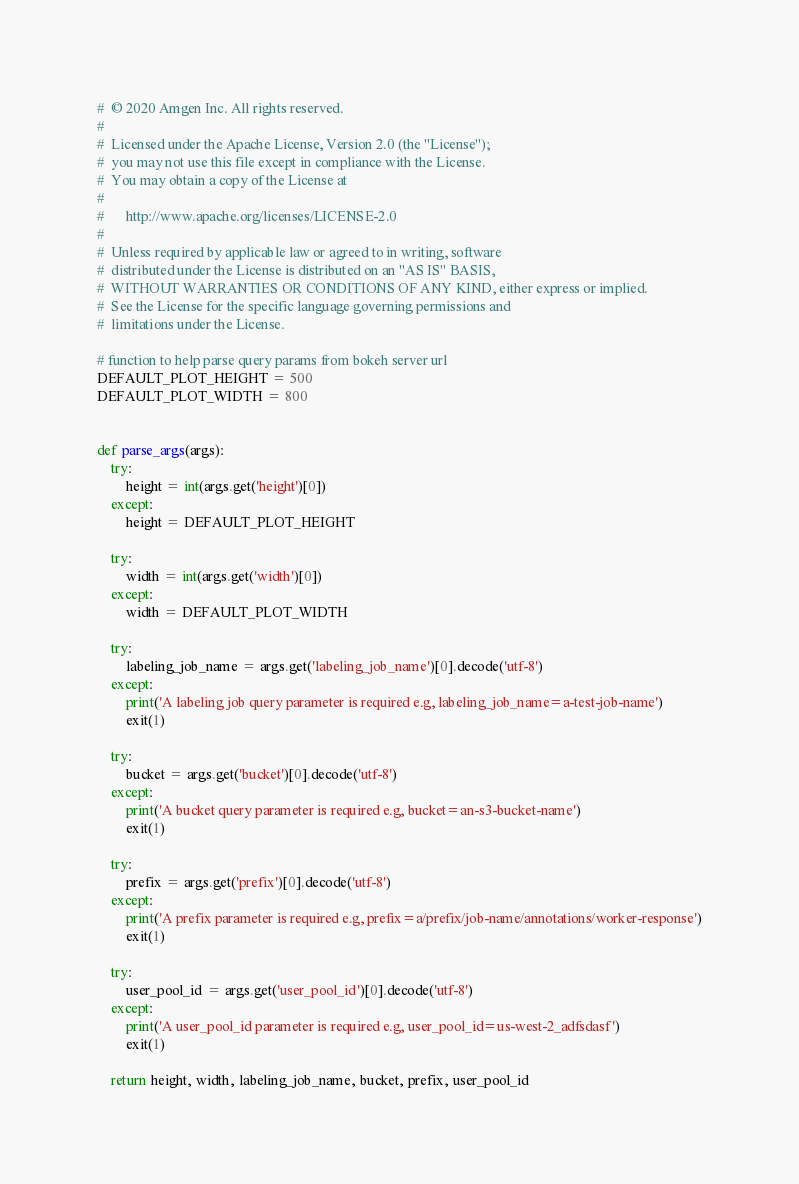Convert code to text. <code><loc_0><loc_0><loc_500><loc_500><_Python_>#  © 2020 Amgen Inc. All rights reserved.
#
#  Licensed under the Apache License, Version 2.0 (the "License");
#  you may not use this file except in compliance with the License.
#  You may obtain a copy of the License at
#
#      http://www.apache.org/licenses/LICENSE-2.0
#
#  Unless required by applicable law or agreed to in writing, software
#  distributed under the License is distributed on an "AS IS" BASIS,
#  WITHOUT WARRANTIES OR CONDITIONS OF ANY KIND, either express or implied.
#  See the License for the specific language governing permissions and
#  limitations under the License.

# function to help parse query params from bokeh server url
DEFAULT_PLOT_HEIGHT = 500
DEFAULT_PLOT_WIDTH = 800


def parse_args(args):
    try:
        height = int(args.get('height')[0])
    except:
        height = DEFAULT_PLOT_HEIGHT

    try:
        width = int(args.get('width')[0])
    except:
        width = DEFAULT_PLOT_WIDTH

    try:
        labeling_job_name = args.get('labeling_job_name')[0].decode('utf-8')
    except:
        print('A labeling job query parameter is required e.g, labeling_job_name=a-test-job-name')
        exit(1)

    try:
        bucket = args.get('bucket')[0].decode('utf-8')
    except:
        print('A bucket query parameter is required e.g, bucket=an-s3-bucket-name')
        exit(1)

    try:
        prefix = args.get('prefix')[0].decode('utf-8')
    except:
        print('A prefix parameter is required e.g, prefix=a/prefix/job-name/annotations/worker-response')
        exit(1)

    try:
        user_pool_id = args.get('user_pool_id')[0].decode('utf-8')
    except:
        print('A user_pool_id parameter is required e.g, user_pool_id=us-west-2_adfsdasf')
        exit(1)

    return height, width, labeling_job_name, bucket, prefix, user_pool_id</code> 